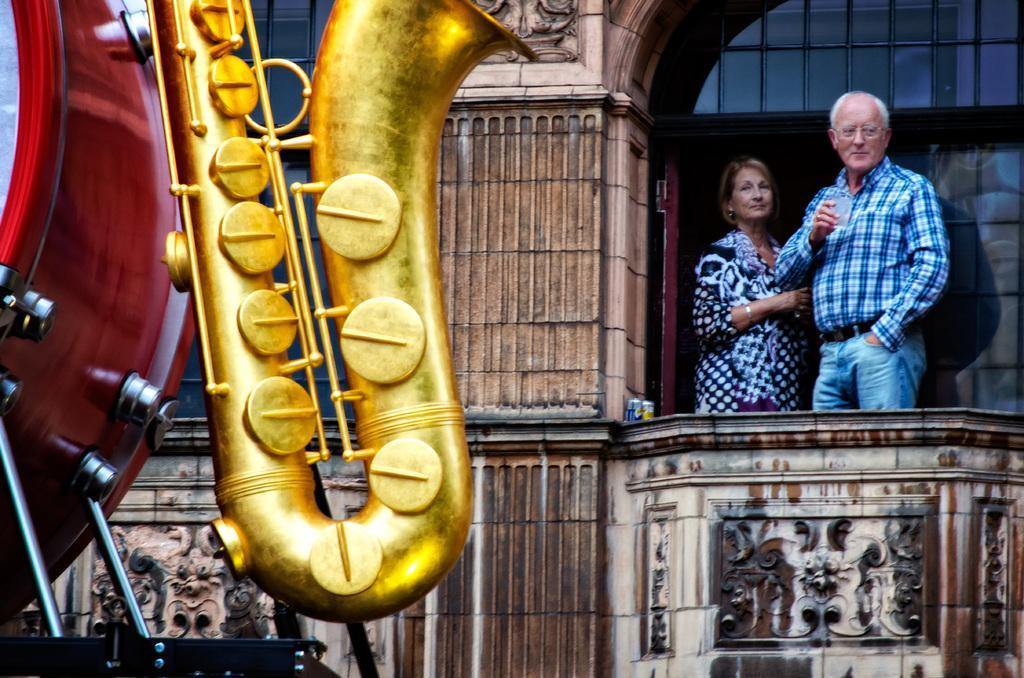How would you summarize this image in a sentence or two? In this image, on the right side, we can see two people man and woman are standing in the balcony. On the left side, we can see a musical instrument. In the background, we can see a building. 